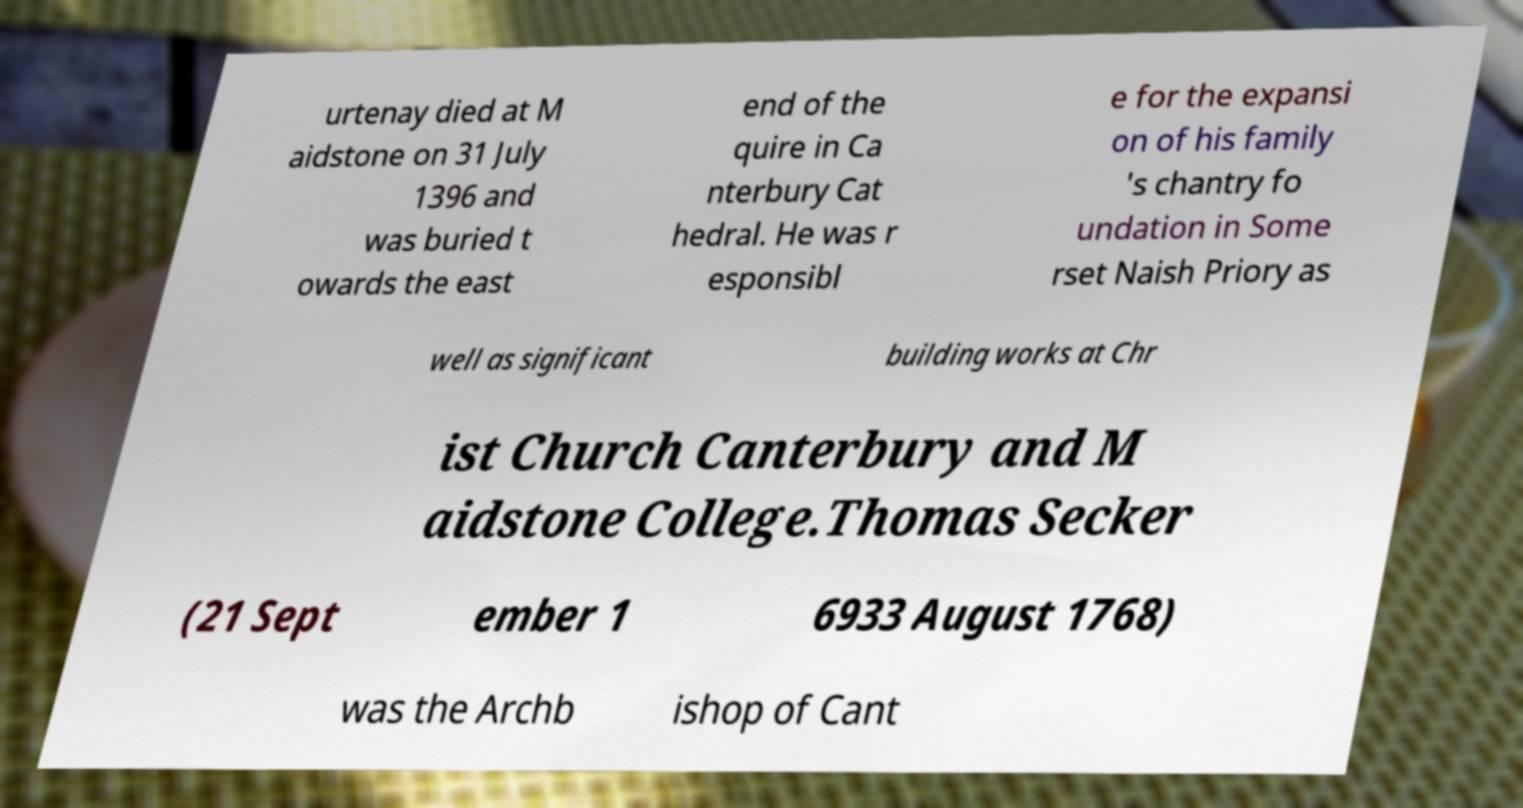I need the written content from this picture converted into text. Can you do that? urtenay died at M aidstone on 31 July 1396 and was buried t owards the east end of the quire in Ca nterbury Cat hedral. He was r esponsibl e for the expansi on of his family 's chantry fo undation in Some rset Naish Priory as well as significant building works at Chr ist Church Canterbury and M aidstone College.Thomas Secker (21 Sept ember 1 6933 August 1768) was the Archb ishop of Cant 